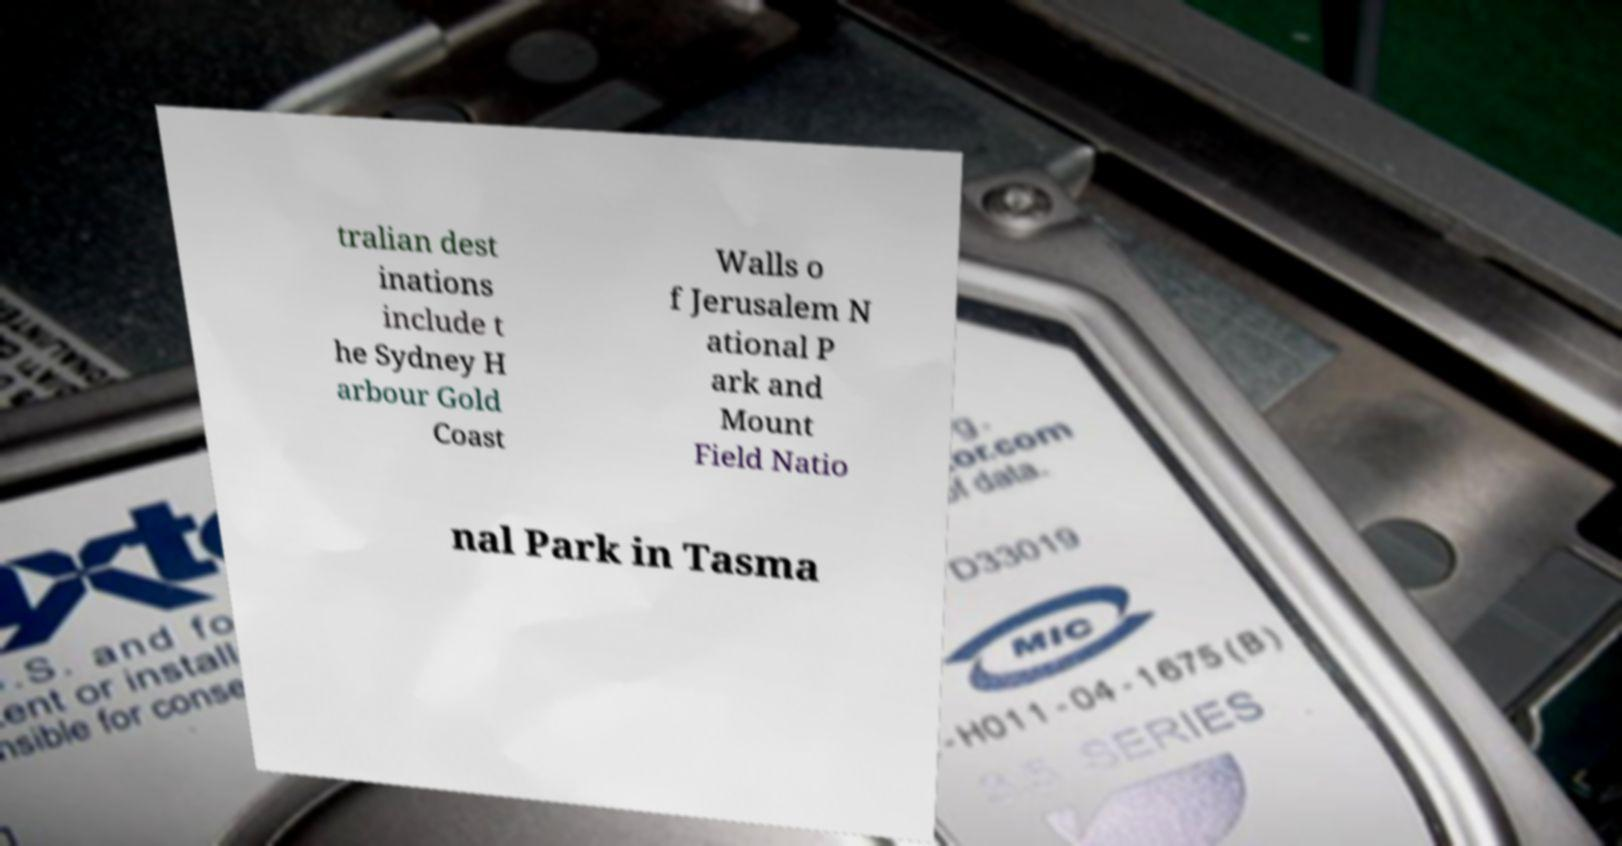Please read and relay the text visible in this image. What does it say? tralian dest inations include t he Sydney H arbour Gold Coast Walls o f Jerusalem N ational P ark and Mount Field Natio nal Park in Tasma 